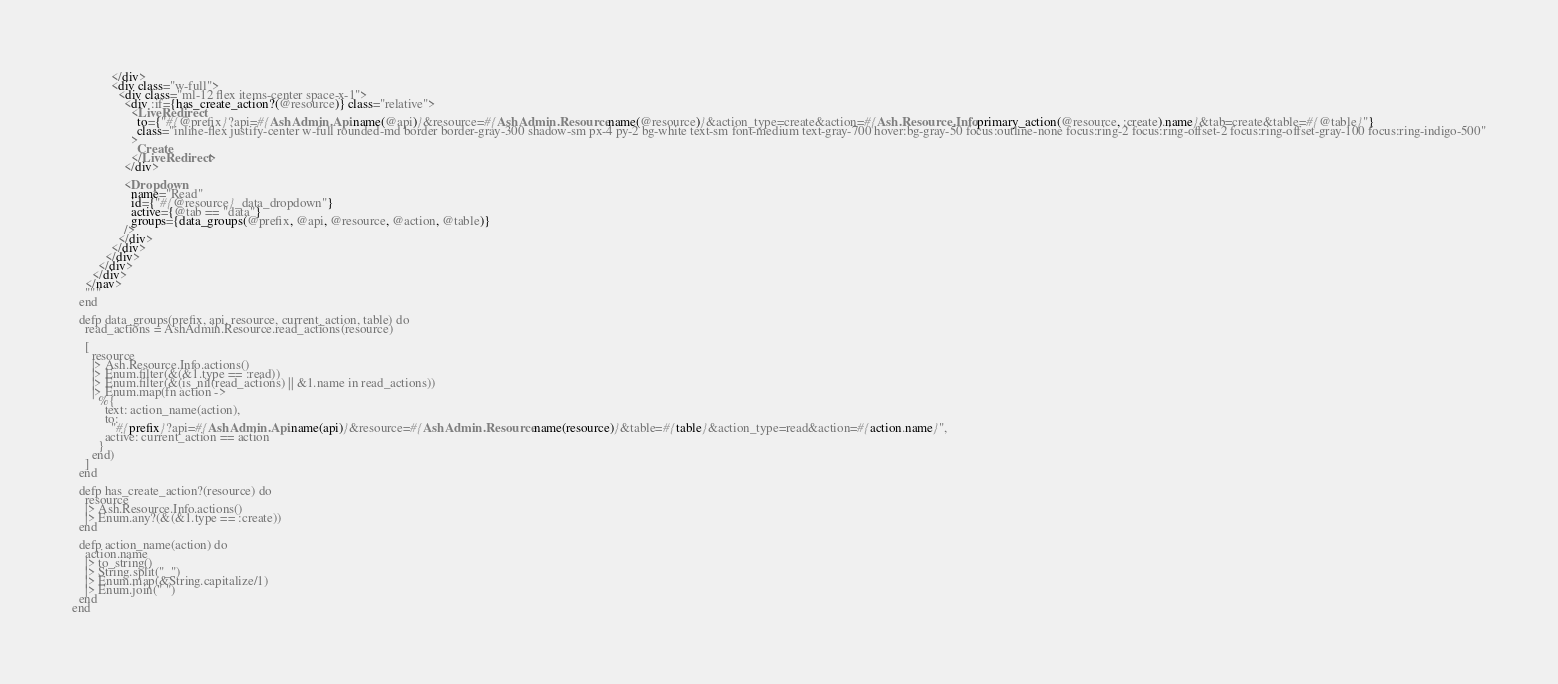<code> <loc_0><loc_0><loc_500><loc_500><_Elixir_>            </div>
            <div class="w-full">
              <div class="ml-12 flex items-center space-x-1">
                <div :if={has_create_action?(@resource)} class="relative">
                  <LiveRedirect
                    to={"#{@prefix}?api=#{AshAdmin.Api.name(@api)}&resource=#{AshAdmin.Resource.name(@resource)}&action_type=create&action=#{Ash.Resource.Info.primary_action(@resource, :create).name}&tab=create&table=#{@table}"}
                    class="inline-flex justify-center w-full rounded-md border border-gray-300 shadow-sm px-4 py-2 bg-white text-sm font-medium text-gray-700 hover:bg-gray-50 focus:outline-none focus:ring-2 focus:ring-offset-2 focus:ring-offset-gray-100 focus:ring-indigo-500"
                  >
                    Create
                  </LiveRedirect>
                </div>

                <Dropdown
                  name="Read"
                  id={"#{@resource}_data_dropdown"}
                  active={@tab == "data"}
                  groups={data_groups(@prefix, @api, @resource, @action, @table)}
                />
              </div>
            </div>
          </div>
        </div>
      </div>
    </nav>
    """
  end

  defp data_groups(prefix, api, resource, current_action, table) do
    read_actions = AshAdmin.Resource.read_actions(resource)

    [
      resource
      |> Ash.Resource.Info.actions()
      |> Enum.filter(&(&1.type == :read))
      |> Enum.filter(&(is_nil(read_actions) || &1.name in read_actions))
      |> Enum.map(fn action ->
        %{
          text: action_name(action),
          to:
            "#{prefix}?api=#{AshAdmin.Api.name(api)}&resource=#{AshAdmin.Resource.name(resource)}&table=#{table}&action_type=read&action=#{action.name}",
          active: current_action == action
        }
      end)
    ]
  end

  defp has_create_action?(resource) do
    resource
    |> Ash.Resource.Info.actions()
    |> Enum.any?(&(&1.type == :create))
  end

  defp action_name(action) do
    action.name
    |> to_string()
    |> String.split("_")
    |> Enum.map(&String.capitalize/1)
    |> Enum.join(" ")
  end
end
</code> 